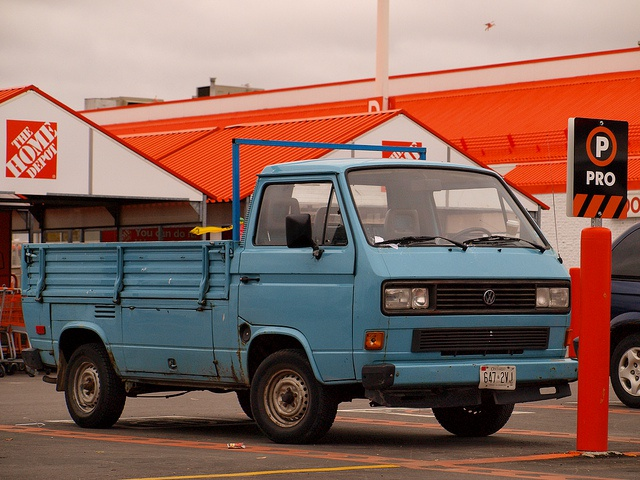Describe the objects in this image and their specific colors. I can see truck in tan, black, gray, and blue tones, car in tan, black, and gray tones, and airplane in tan, brown, lightpink, and salmon tones in this image. 